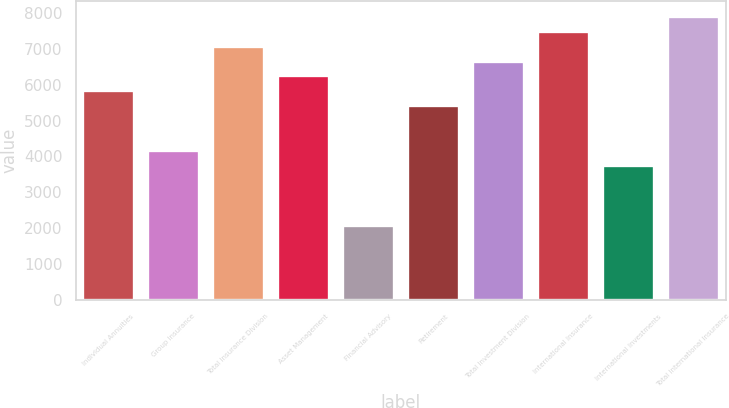Convert chart to OTSL. <chart><loc_0><loc_0><loc_500><loc_500><bar_chart><fcel>Individual Annuities<fcel>Group Insurance<fcel>Total Insurance Division<fcel>Asset Management<fcel>Financial Advisory<fcel>Retirement<fcel>Total Investment Division<fcel>International Insurance<fcel>International Investments<fcel>Total International Insurance<nl><fcel>5839.2<fcel>4174<fcel>7088.1<fcel>6255.5<fcel>2092.5<fcel>5422.9<fcel>6671.8<fcel>7504.4<fcel>3757.7<fcel>7920.7<nl></chart> 